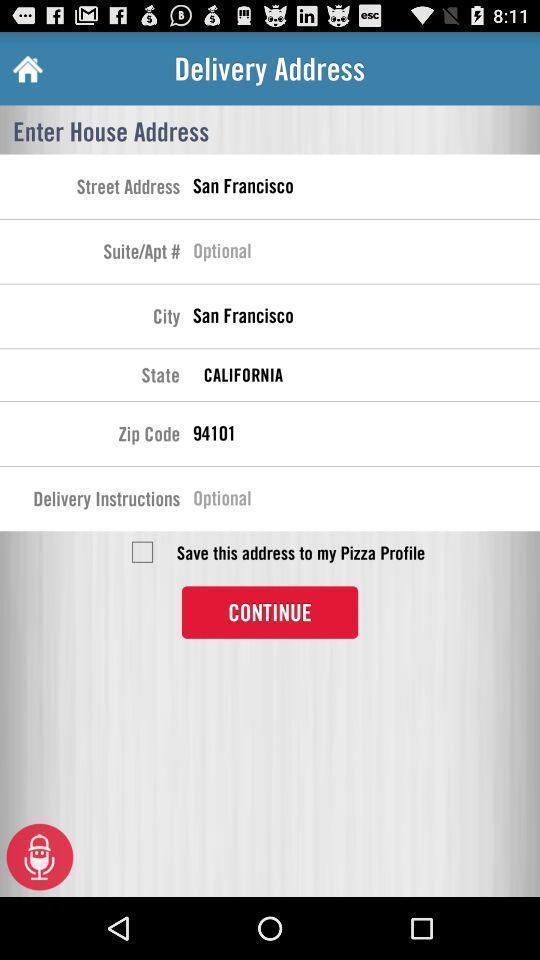Explain what's happening in this screen capture. Screen displaying options in address page of a food application. 